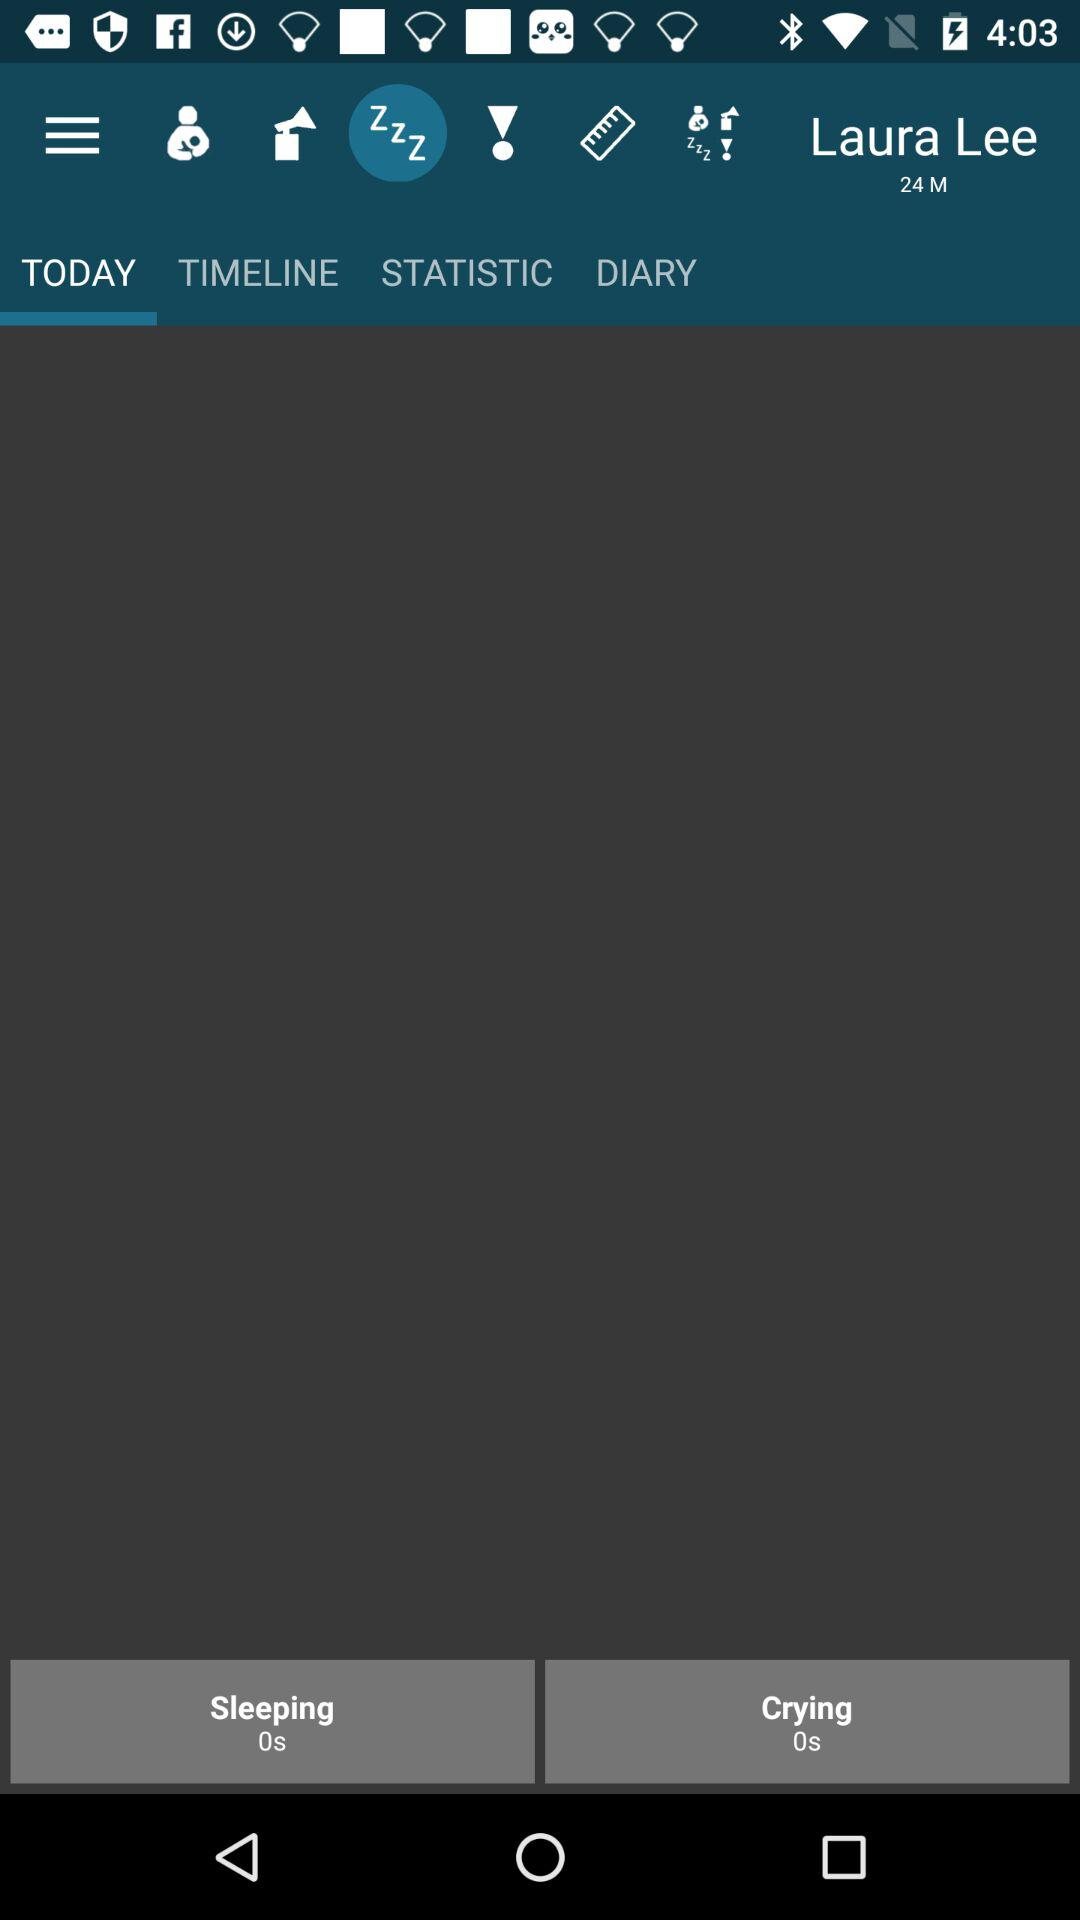Which tab is selected? The selected tab is "TODAY". 